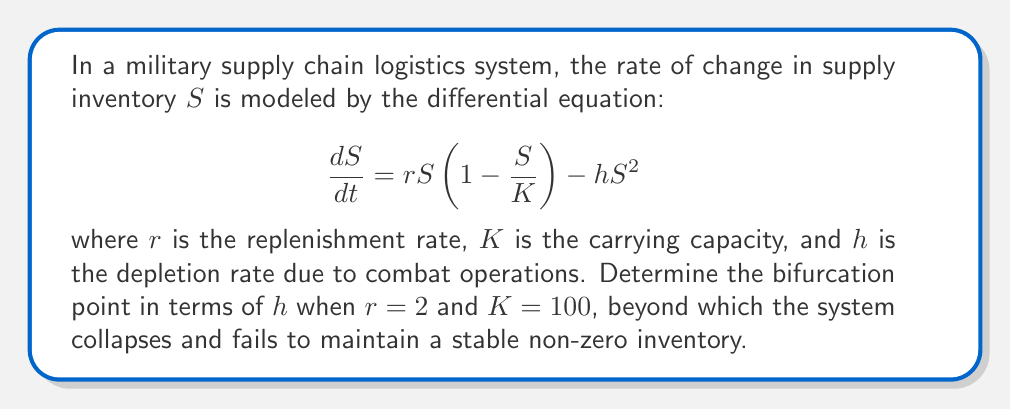Teach me how to tackle this problem. To find the bifurcation point, we need to analyze the equilibrium points of the system and determine when they change stability. Let's proceed step-by-step:

1) First, set $\frac{dS}{dt} = 0$ to find the equilibrium points:

   $$rS(1-\frac{S}{K}) - hS^2 = 0$$

2) Factor out $S$:

   $$S(r(1-\frac{S}{K}) - hS) = 0$$

3) Solve for $S$:
   
   $S = 0$ or $r(1-\frac{S}{K}) - hS = 0$

4) For the non-zero equilibrium, solve:

   $$r - \frac{rS}{K} - hS = 0$$
   $$r = S(\frac{r}{K} + h)$$
   $$S = \frac{r}{\frac{r}{K} + h} = \frac{rK}{r + Kh}$$

5) Substitute the given values $r=2$ and $K=100$:

   $$S = \frac{200}{2 + 100h}$$

6) The bifurcation occurs when this non-zero equilibrium coincides with the zero equilibrium. This happens when the denominator equals the numerator:

   $$2 + 100h = 200$$
   $$100h = 198$$
   $$h = 1.98$$

7) Beyond this point, the non-zero equilibrium becomes negative and biologically meaningless, indicating system collapse.
Answer: $h = 1.98$ 